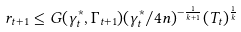Convert formula to latex. <formula><loc_0><loc_0><loc_500><loc_500>r _ { t + 1 } \leq G ( \gamma _ { t } ^ { * } , \Gamma _ { t + 1 } ) ( \gamma _ { t } ^ { * } / 4 n ) ^ { - \frac { 1 } { k + 1 } } ( T _ { t } ) ^ { \frac { 1 } { k } }</formula> 